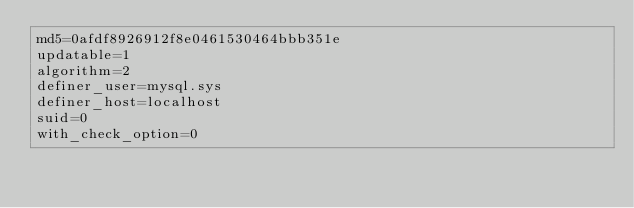Convert code to text. <code><loc_0><loc_0><loc_500><loc_500><_VisualBasic_>md5=0afdf8926912f8e0461530464bbb351e
updatable=1
algorithm=2
definer_user=mysql.sys
definer_host=localhost
suid=0
with_check_option=0</code> 